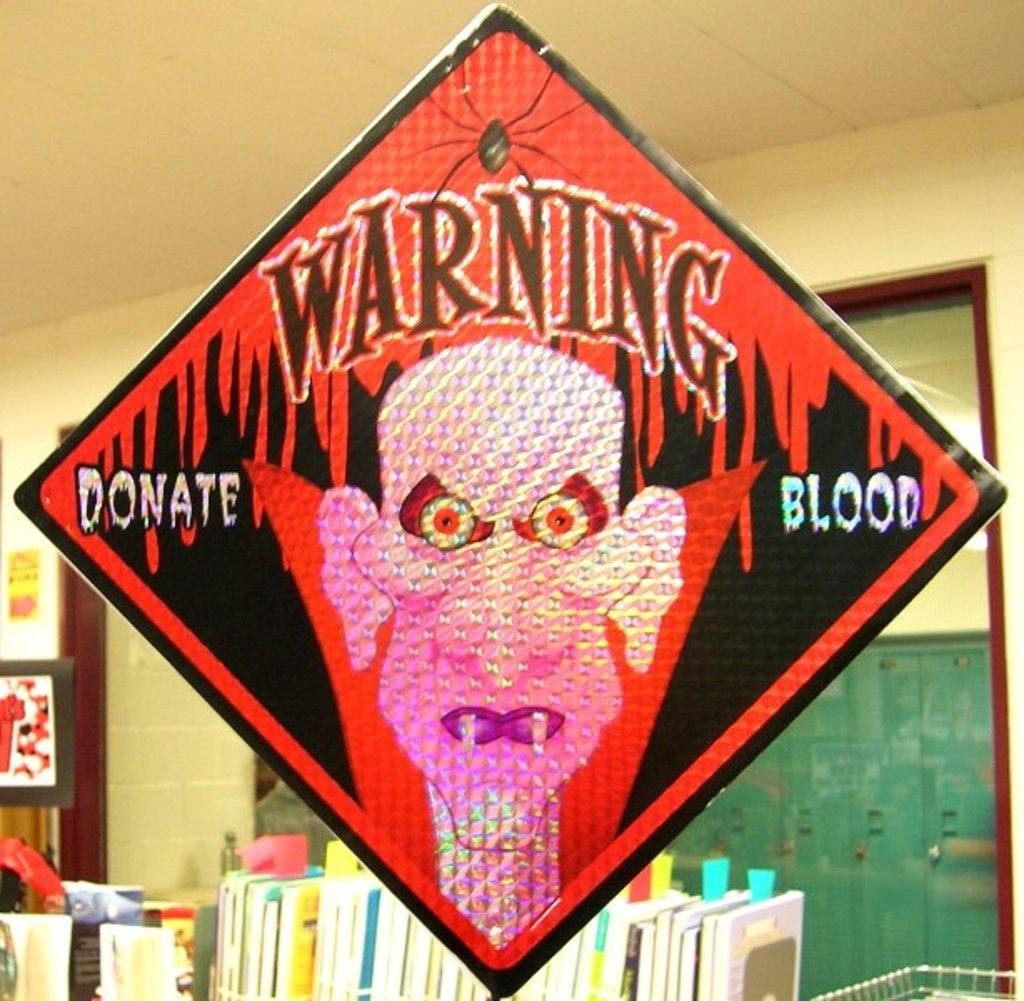<image>
Relay a brief, clear account of the picture shown. A diamond sign that warns people to donate blood. 